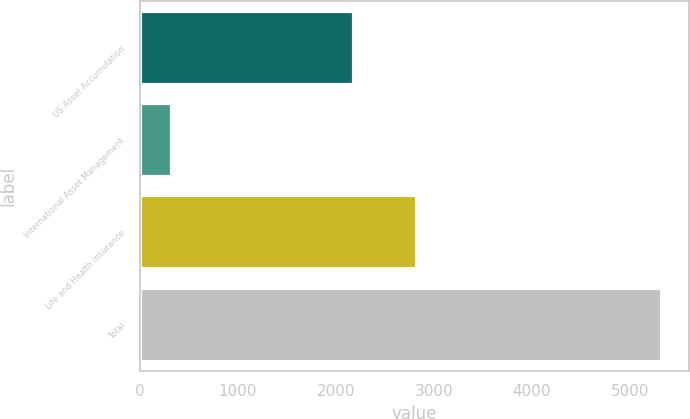Convert chart. <chart><loc_0><loc_0><loc_500><loc_500><bar_chart><fcel>US Asset Accumulation<fcel>International Asset Management<fcel>Life and Health Insurance<fcel>Total<nl><fcel>2185.1<fcel>328.5<fcel>2832.4<fcel>5334.5<nl></chart> 